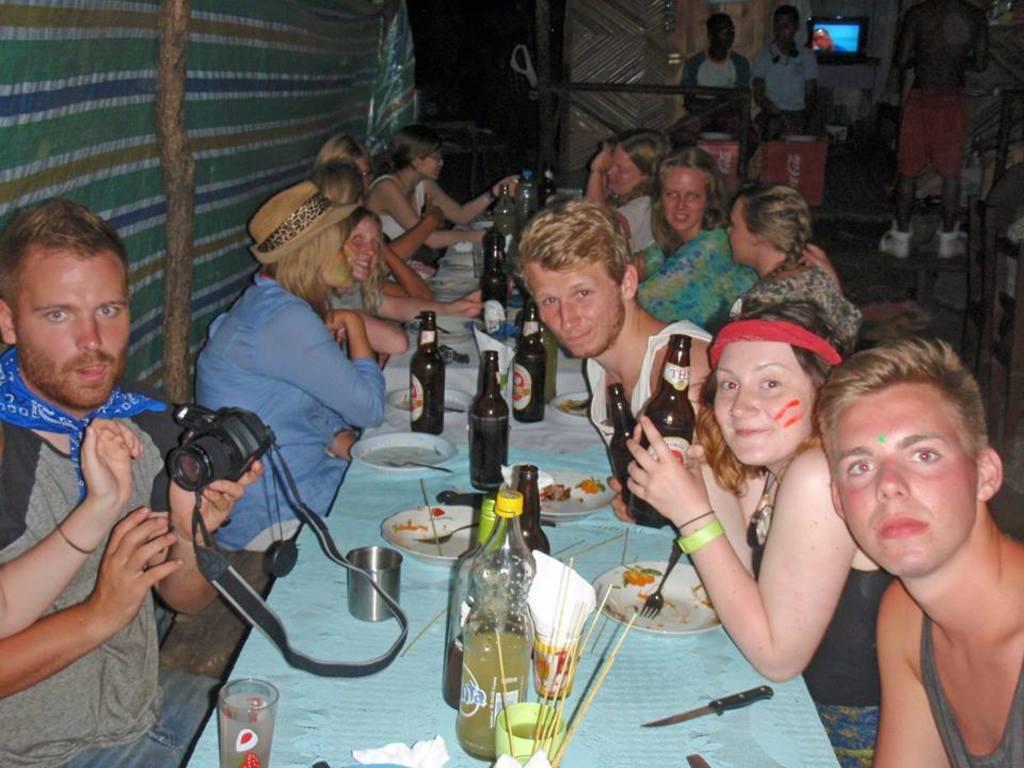How would you summarize this image in a sentence or two? In this picture i could see some persons around the dining table having a snack there are some beer bottles, plates, forks, sticks, glasses and to the left a person is holding a camera. In the background i could see a television and two persons standing. 